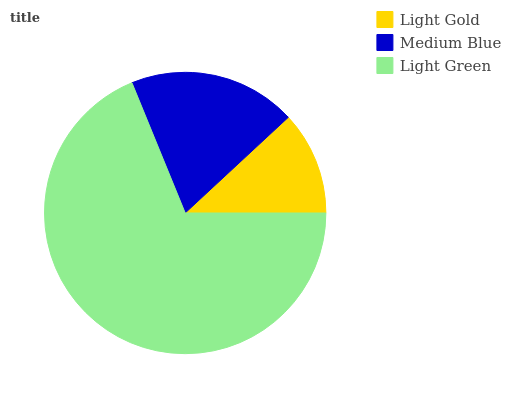Is Light Gold the minimum?
Answer yes or no. Yes. Is Light Green the maximum?
Answer yes or no. Yes. Is Medium Blue the minimum?
Answer yes or no. No. Is Medium Blue the maximum?
Answer yes or no. No. Is Medium Blue greater than Light Gold?
Answer yes or no. Yes. Is Light Gold less than Medium Blue?
Answer yes or no. Yes. Is Light Gold greater than Medium Blue?
Answer yes or no. No. Is Medium Blue less than Light Gold?
Answer yes or no. No. Is Medium Blue the high median?
Answer yes or no. Yes. Is Medium Blue the low median?
Answer yes or no. Yes. Is Light Gold the high median?
Answer yes or no. No. Is Light Gold the low median?
Answer yes or no. No. 